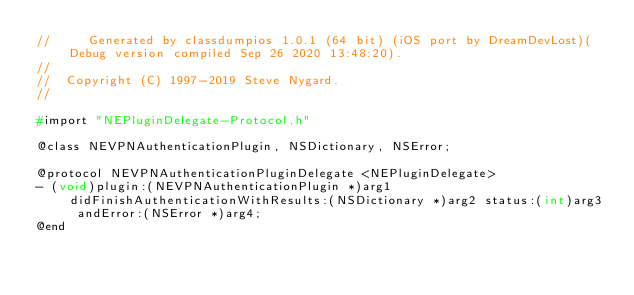<code> <loc_0><loc_0><loc_500><loc_500><_C_>//     Generated by classdumpios 1.0.1 (64 bit) (iOS port by DreamDevLost)(Debug version compiled Sep 26 2020 13:48:20).
//
//  Copyright (C) 1997-2019 Steve Nygard.
//

#import "NEPluginDelegate-Protocol.h"

@class NEVPNAuthenticationPlugin, NSDictionary, NSError;

@protocol NEVPNAuthenticationPluginDelegate <NEPluginDelegate>
- (void)plugin:(NEVPNAuthenticationPlugin *)arg1 didFinishAuthenticationWithResults:(NSDictionary *)arg2 status:(int)arg3 andError:(NSError *)arg4;
@end

</code> 